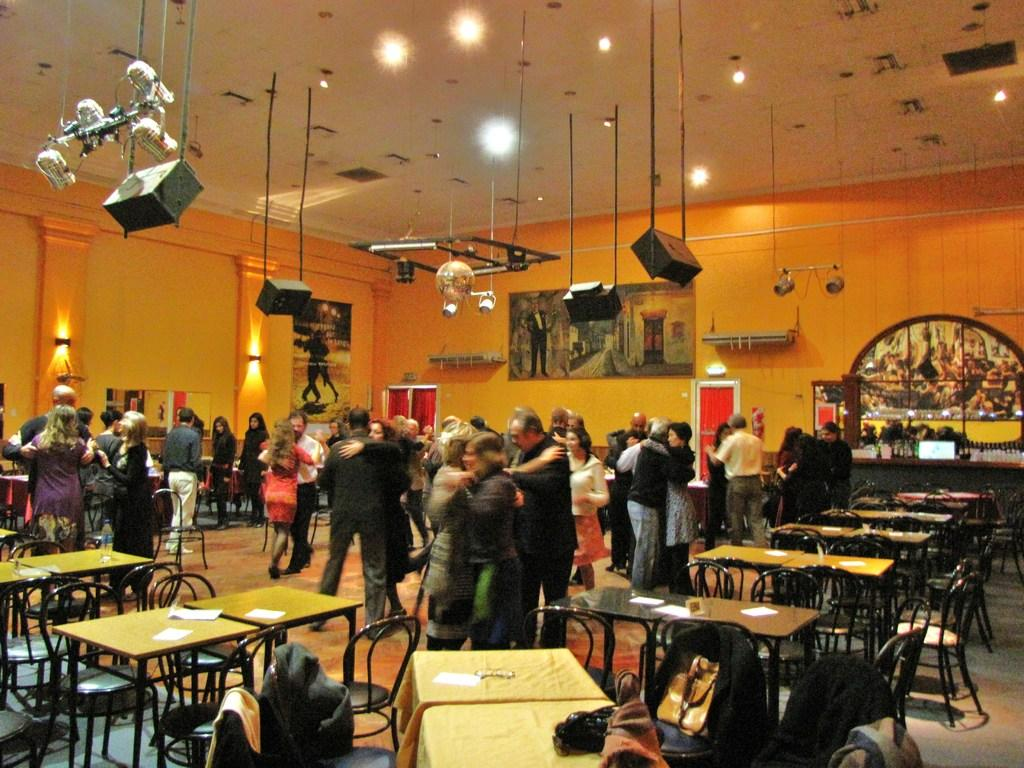How many people are in the group that is visible in the image? There is a group of people in the image, but the exact number is not specified. What are the people in the group doing? The people are standing, and some of them are dancing as couples. What type of furniture is present in the image? Chairs and tables are present in the image. What is located on the roof in the image? There are lights on the roof. What devices are visible in the image that might be used for amplifying sound? Sound boxes are visible in the image. What type of twig can be seen in the image? There is no twig present in the image. What shape is the place where the people are standing? The shape of the place where the people are standing is not specified in the image. 